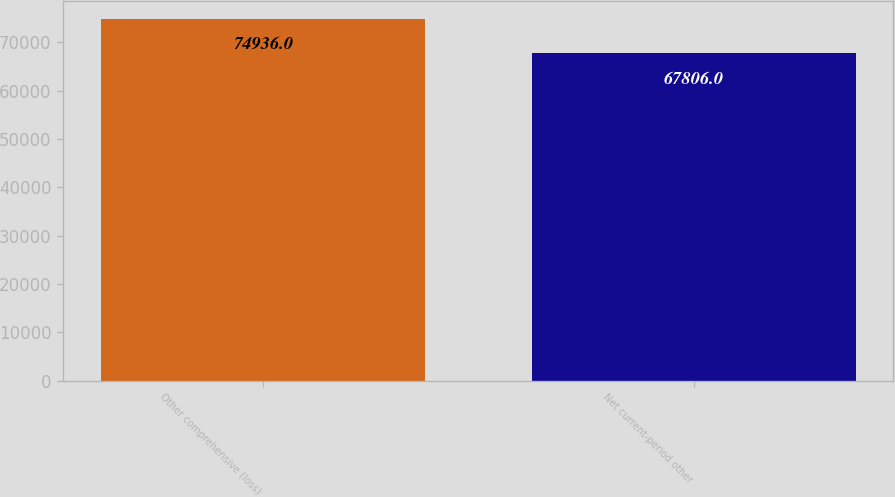<chart> <loc_0><loc_0><loc_500><loc_500><bar_chart><fcel>Other comprehensive (loss)<fcel>Net current-period other<nl><fcel>74936<fcel>67806<nl></chart> 